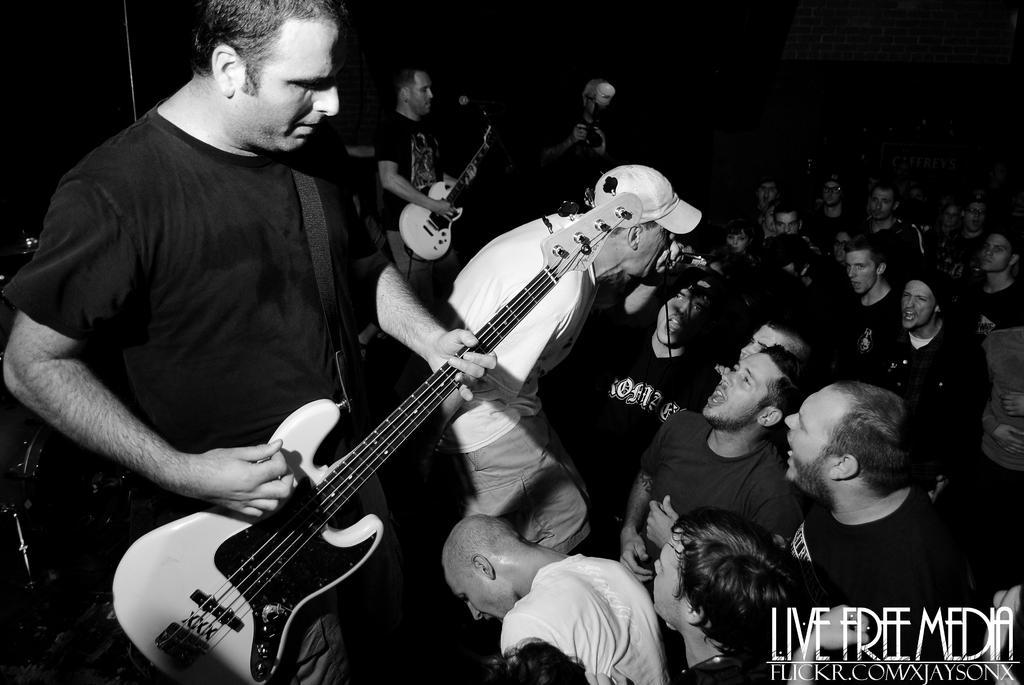Please provide a concise description of this image. It is a music concert there are some people playing the guitar and the middle person wearing hat is singing a song,in front of that there are many people standing,they are enjoying the music in the background there is a brick wall. 